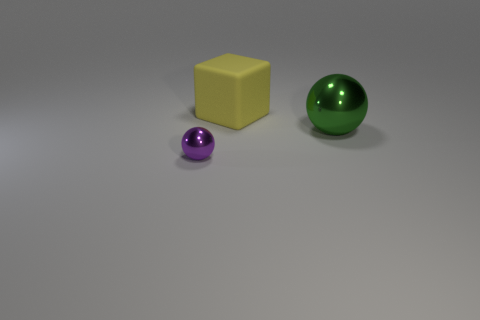Add 2 metallic balls. How many objects exist? 5 Subtract 1 balls. How many balls are left? 1 Subtract all cubes. How many objects are left? 2 Add 1 green metal objects. How many green metal objects are left? 2 Add 3 large shiny spheres. How many large shiny spheres exist? 4 Subtract 0 gray cylinders. How many objects are left? 3 Subtract all brown blocks. Subtract all green balls. How many blocks are left? 1 Subtract all small metallic things. Subtract all yellow objects. How many objects are left? 1 